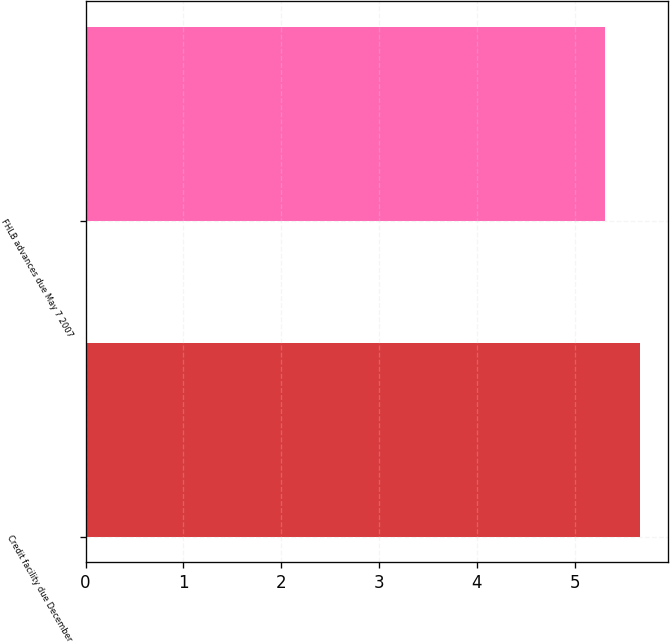Convert chart to OTSL. <chart><loc_0><loc_0><loc_500><loc_500><bar_chart><fcel>Credit facility due December<fcel>FHLB advances due May 7 2007<nl><fcel>5.67<fcel>5.31<nl></chart> 